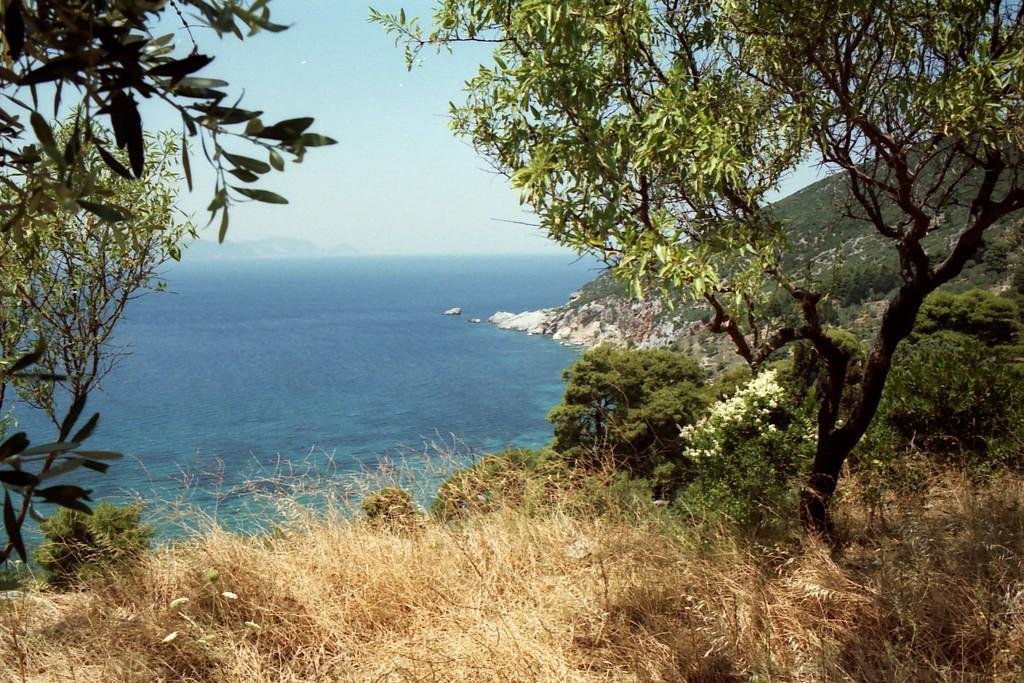What type of vegetation can be seen in the image? There is a group of plants, some flowers, and trees in the image. What natural features are visible in the image? The hills and a water body are visible in the image. What is the condition of the sky in the image? The sky is visible in the image and appears cloudy. What plot of land does the self-driving car navigate in the image? There is no self-driving car present in the image, so it is not possible to answer that question. 